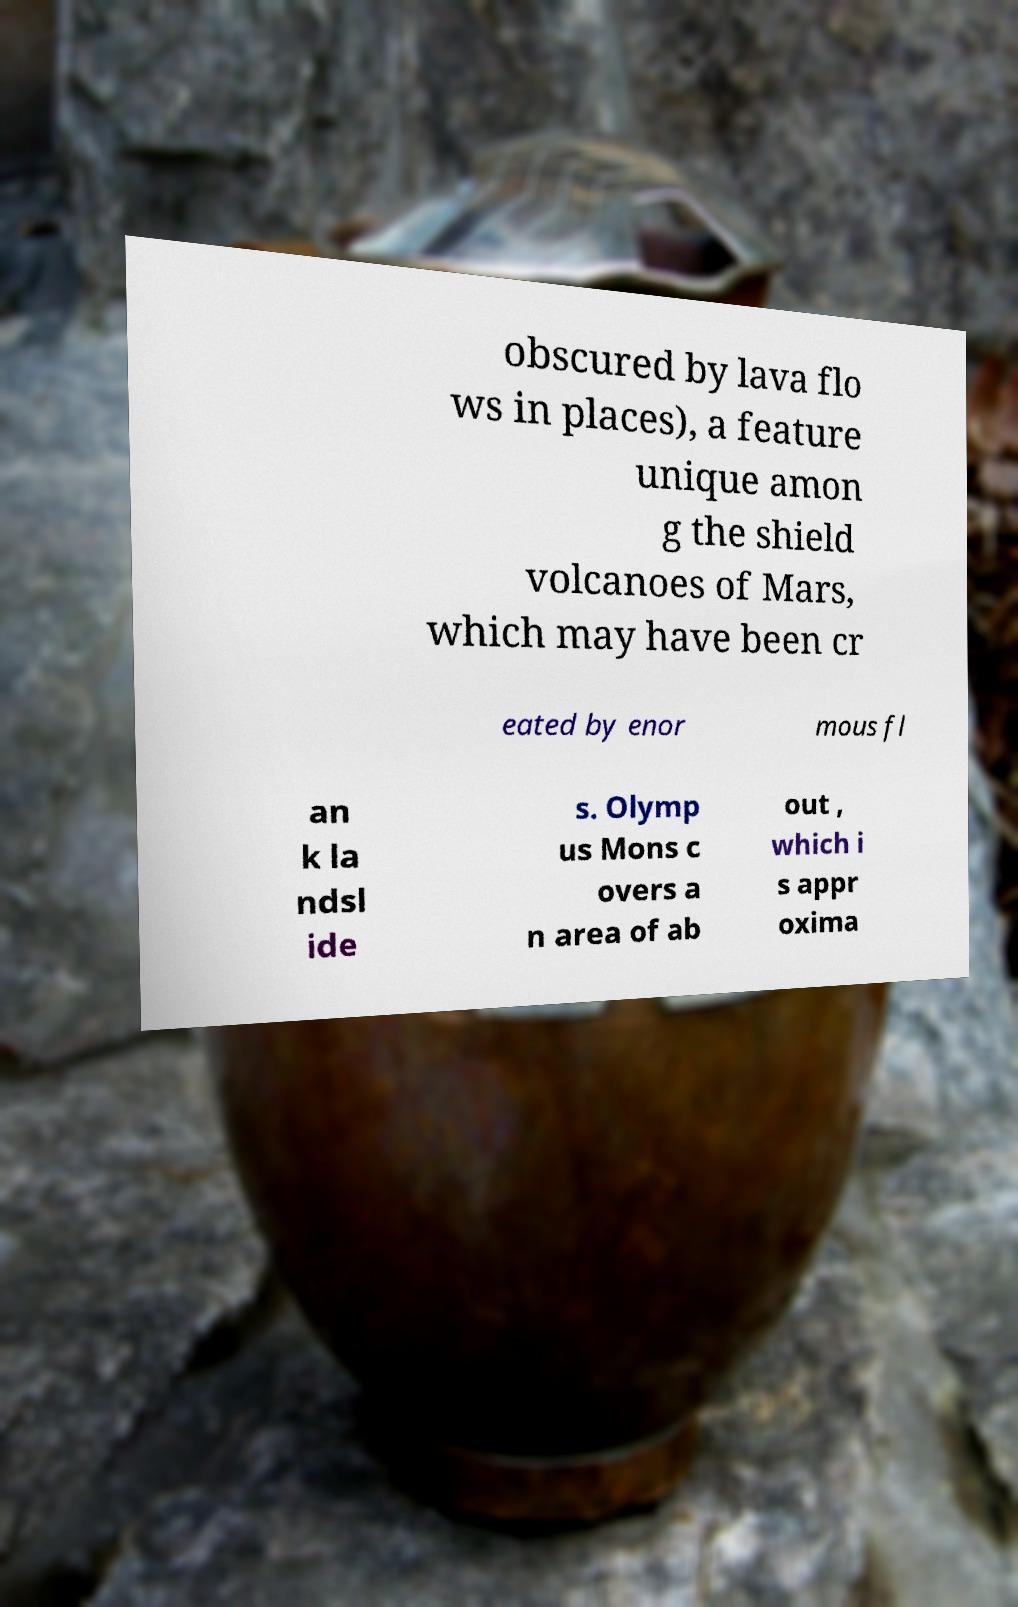Could you extract and type out the text from this image? obscured by lava flo ws in places), a feature unique amon g the shield volcanoes of Mars, which may have been cr eated by enor mous fl an k la ndsl ide s. Olymp us Mons c overs a n area of ab out , which i s appr oxima 